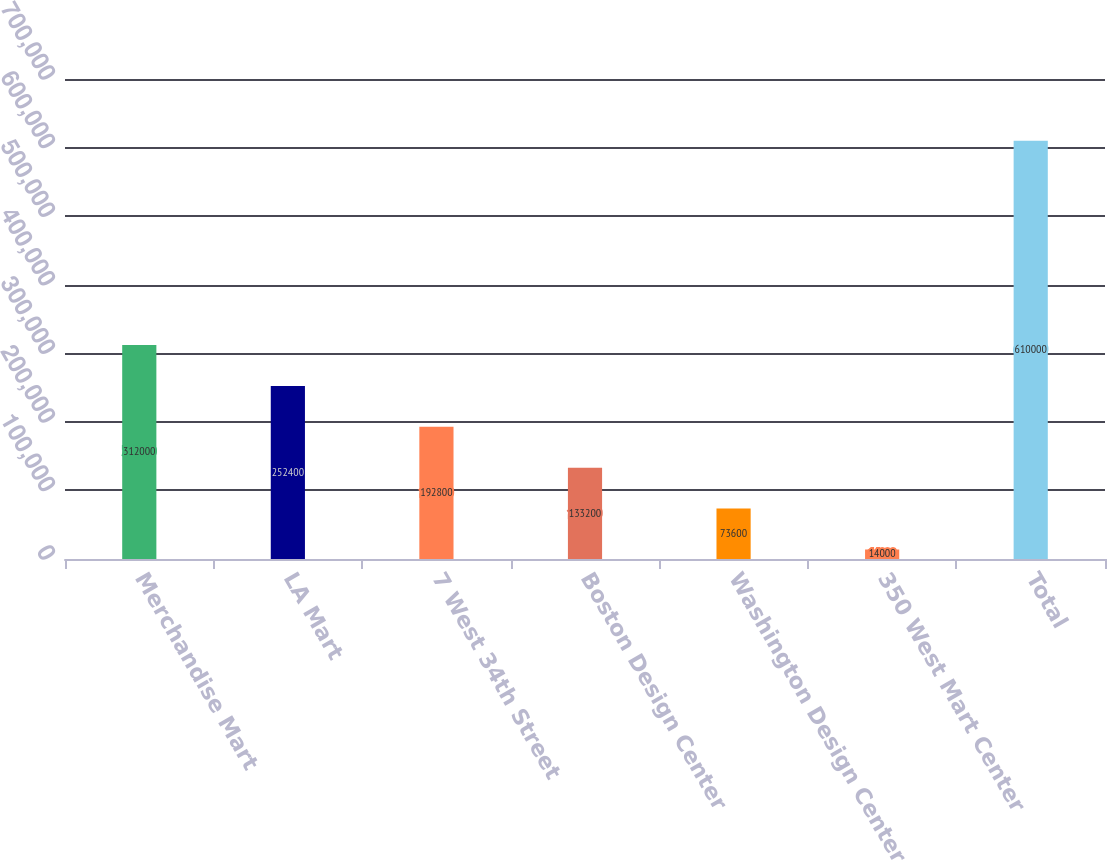Convert chart to OTSL. <chart><loc_0><loc_0><loc_500><loc_500><bar_chart><fcel>Merchandise Mart<fcel>LA Mart<fcel>7 West 34th Street<fcel>Boston Design Center<fcel>Washington Design Center<fcel>350 West Mart Center<fcel>Total<nl><fcel>312000<fcel>252400<fcel>192800<fcel>133200<fcel>73600<fcel>14000<fcel>610000<nl></chart> 